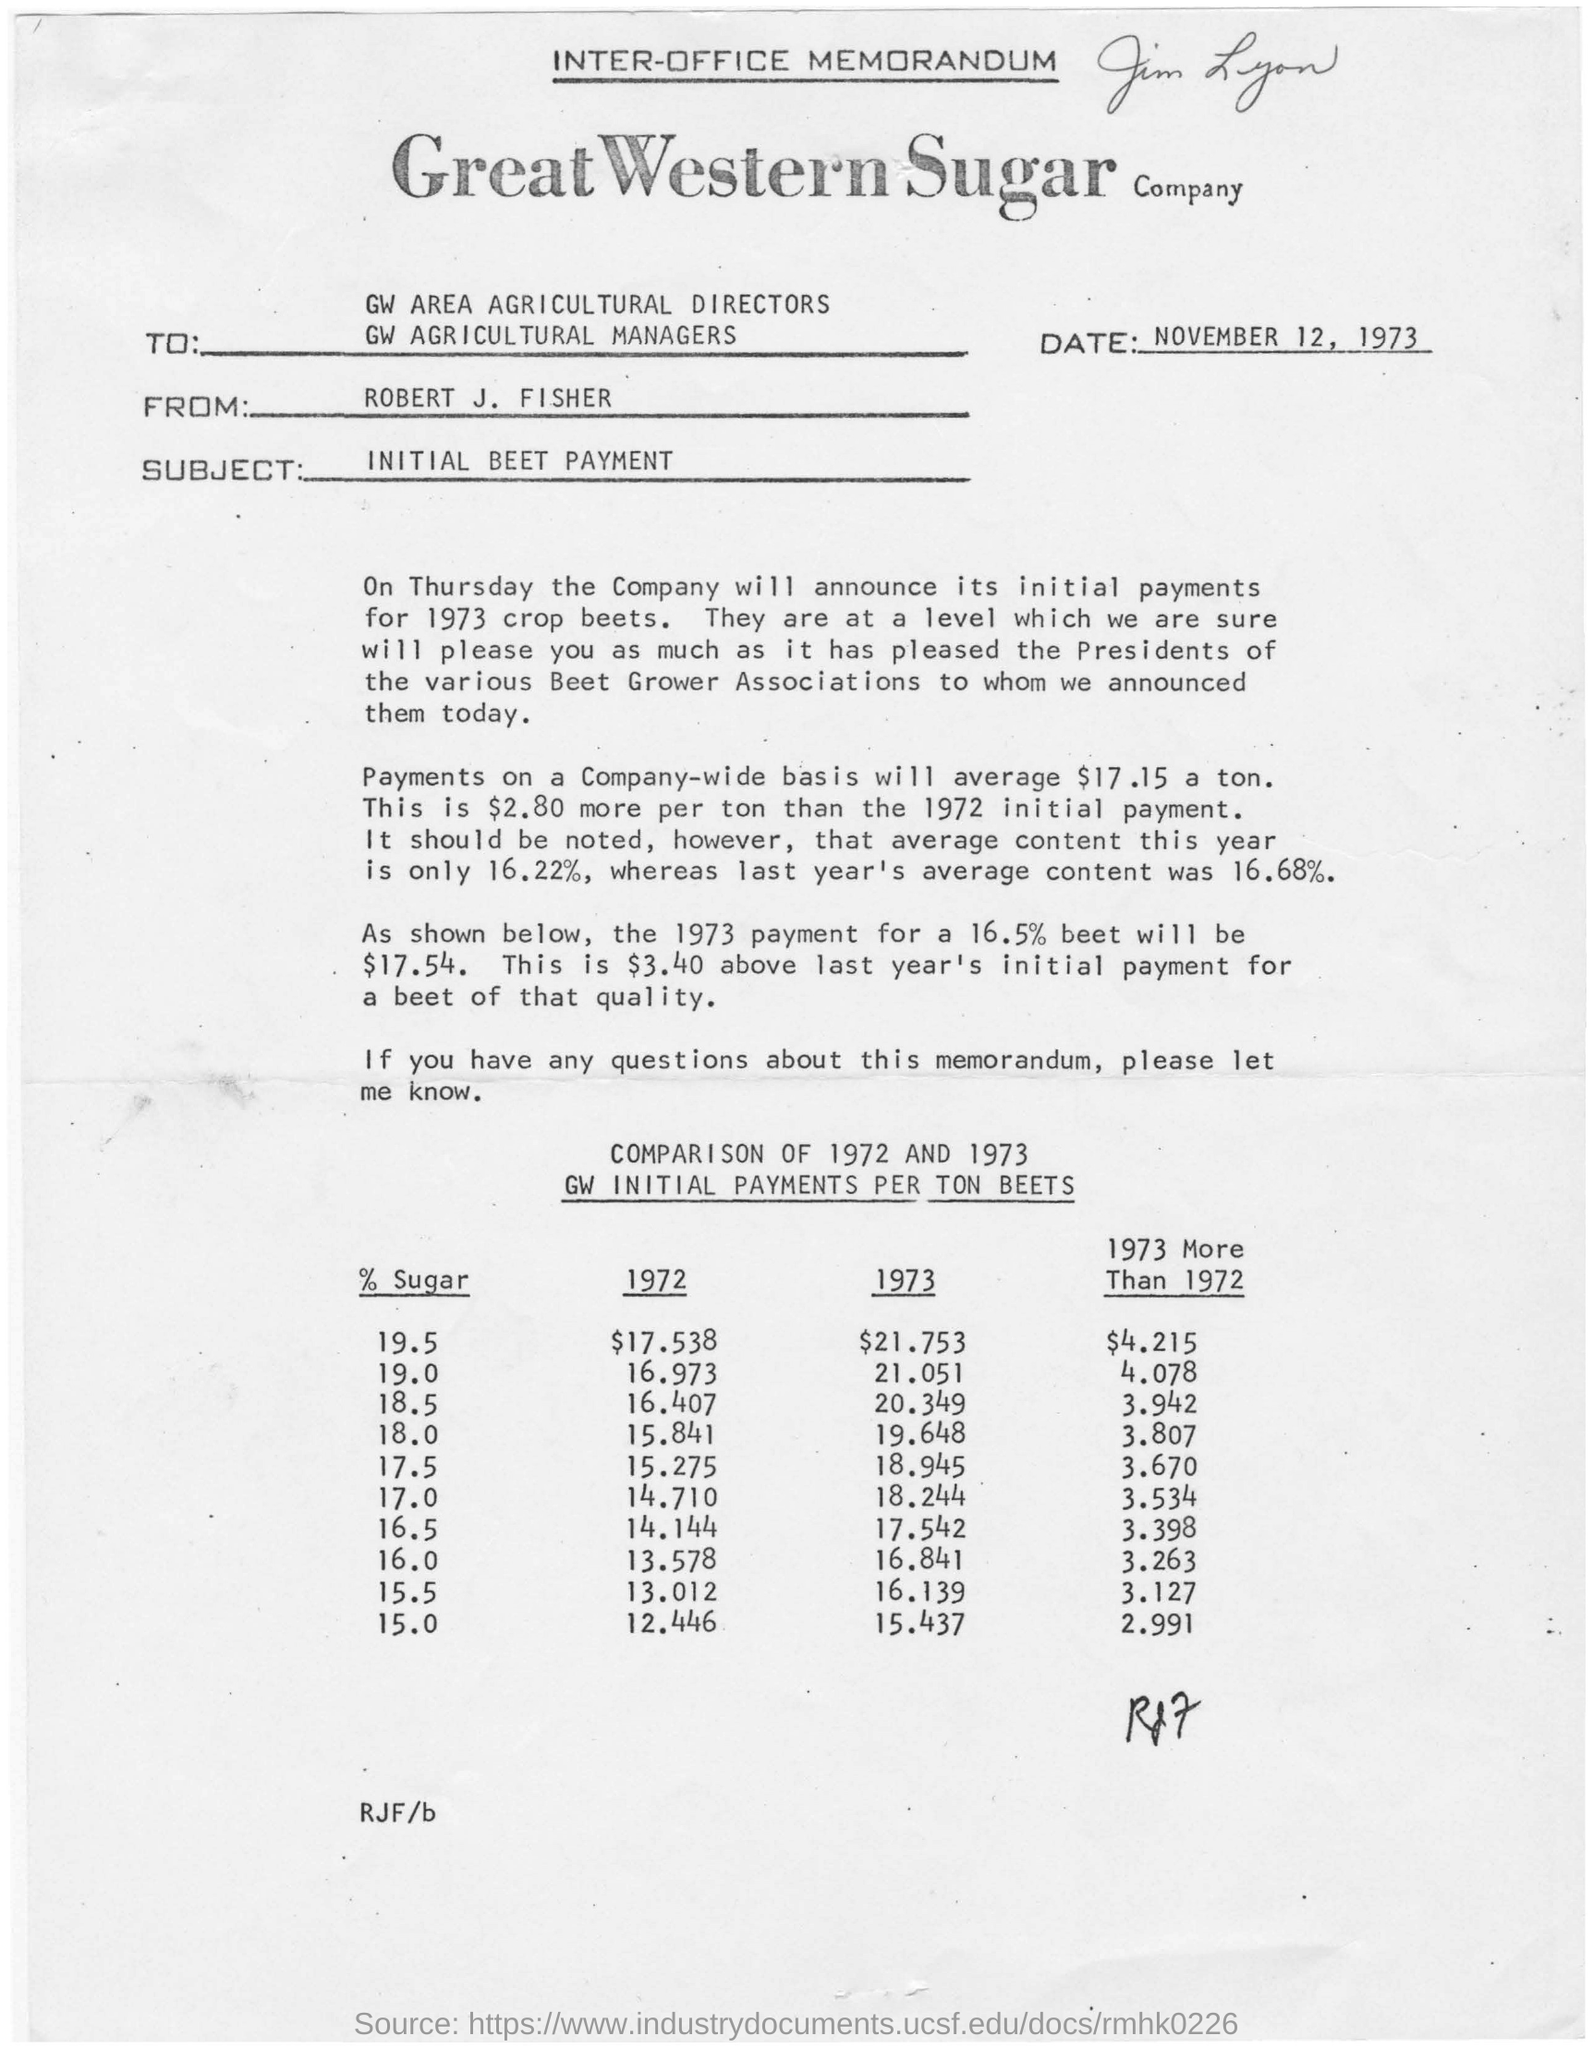What is the date in the memorandum?
Provide a short and direct response. November 12, 1973. Who is the memorandum from?
Keep it short and to the point. ROBERT J. FISHER. 